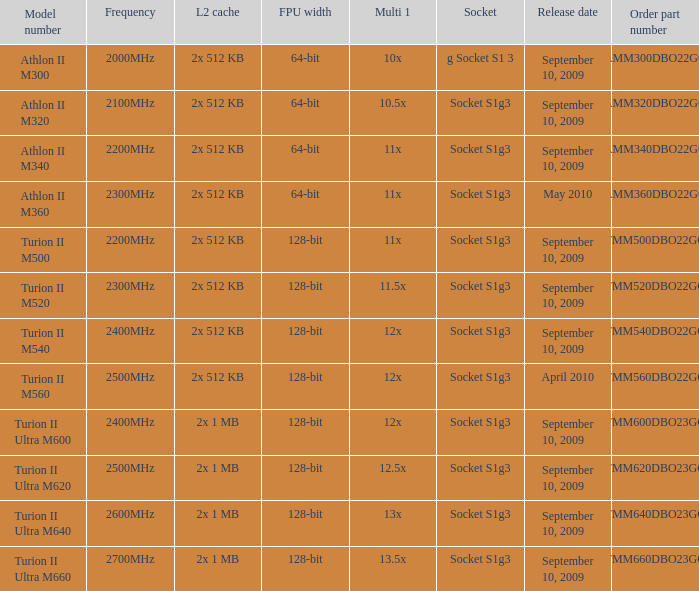What is the socket with an order part number of amm300dbo22gq and a September 10, 2009 release date? G socket s1 3. 